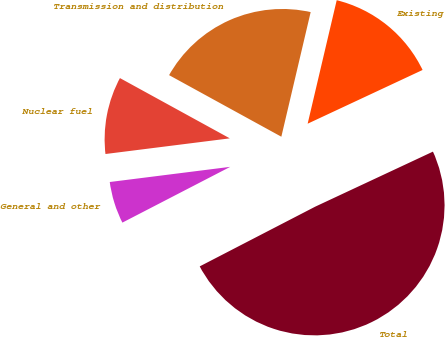Convert chart to OTSL. <chart><loc_0><loc_0><loc_500><loc_500><pie_chart><fcel>Existing<fcel>Transmission and distribution<fcel>Nuclear fuel<fcel>General and other<fcel>Total<nl><fcel>14.36%<fcel>20.69%<fcel>9.98%<fcel>5.6%<fcel>49.36%<nl></chart> 